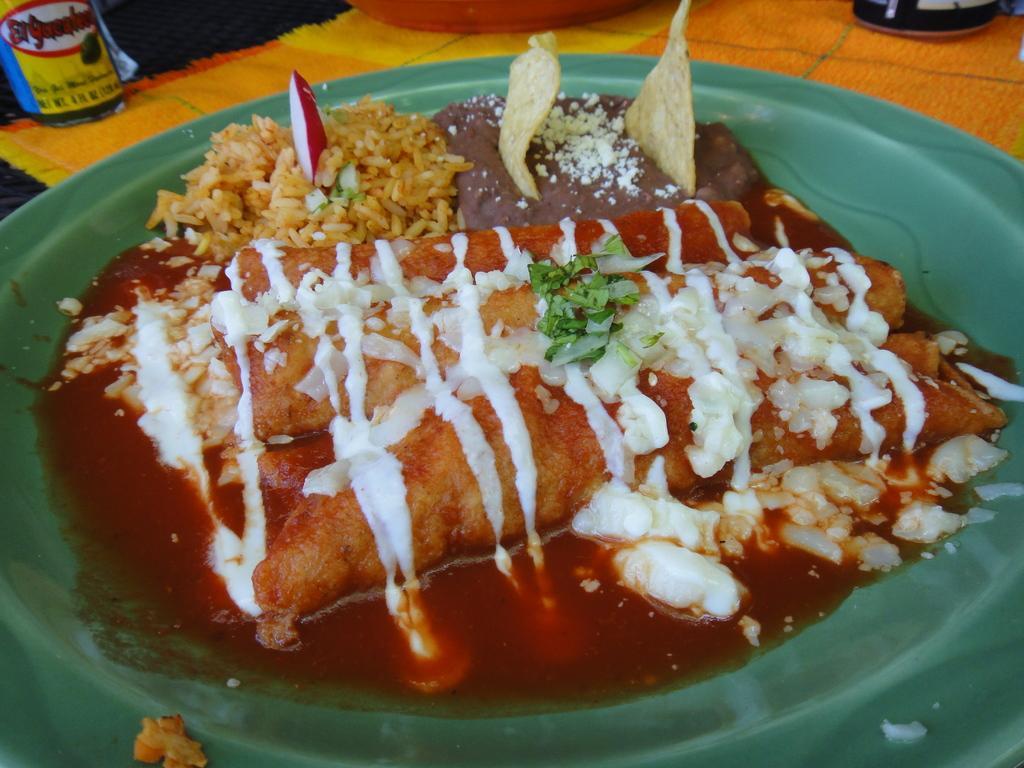Please provide a concise description of this image. In this image I can see a green colour plate in the front and on it I can see different types of food. In the background I can see few things and on the top left corner of this image I can see something is written. 